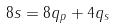Convert formula to latex. <formula><loc_0><loc_0><loc_500><loc_500>8 s = 8 q _ { p } + 4 q _ { s }</formula> 